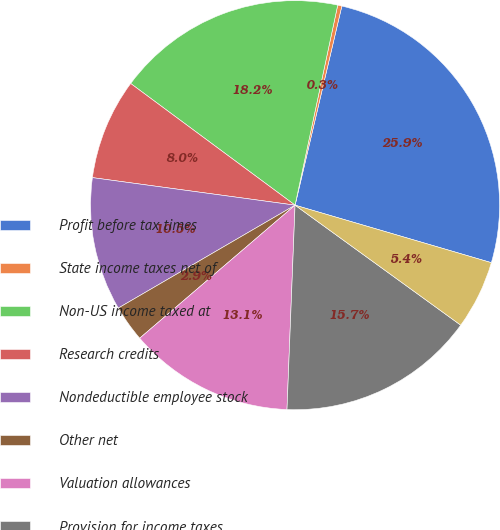<chart> <loc_0><loc_0><loc_500><loc_500><pie_chart><fcel>Profit before tax times<fcel>State income taxes net of<fcel>Non-US income taxed at<fcel>Research credits<fcel>Nondeductible employee stock<fcel>Other net<fcel>Valuation allowances<fcel>Provision for income taxes<fcel>Effective tax rate<nl><fcel>25.86%<fcel>0.33%<fcel>18.2%<fcel>7.99%<fcel>10.54%<fcel>2.88%<fcel>13.1%<fcel>15.65%<fcel>5.44%<nl></chart> 